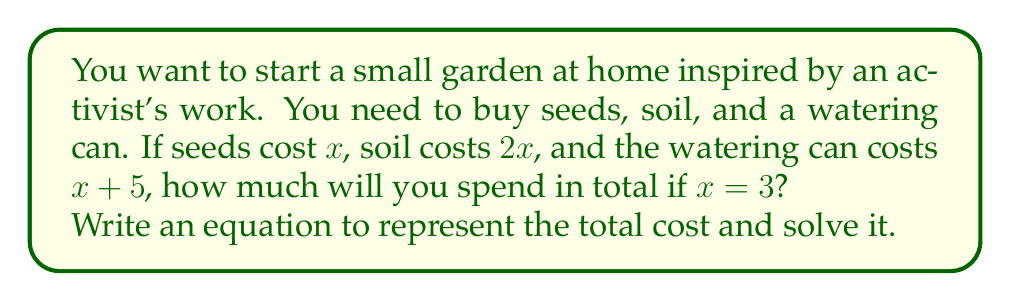What is the answer to this math problem? Let's approach this step-by-step:

1) First, let's define our variables:
   $x$ = cost of seeds
   $2x$ = cost of soil
   $x + 5$ = cost of watering can

2) We can write an equation for the total cost:
   Total cost = cost of seeds + cost of soil + cost of watering can
   $$ \text{Total} = x + 2x + (x + 5) $$

3) Simplify the right side of the equation:
   $$ \text{Total} = x + 2x + x + 5 $$
   $$ \text{Total} = 4x + 5 $$

4) Now, we're told that $x = 3$. Let's substitute this value:
   $$ \text{Total} = 4(3) + 5 $$

5) Solve the equation:
   $$ \text{Total} = 12 + 5 = 17 $$

Therefore, the total cost of the gardening supplies is $17.
Answer: $17 